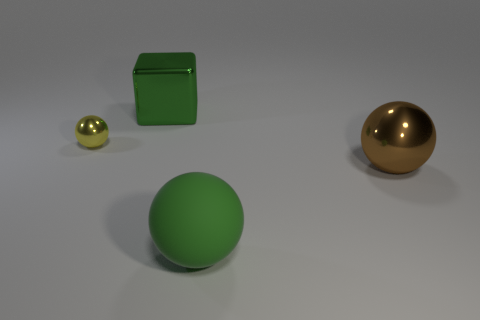What could the different sizes of the spheres suggest if this were an illustration for a story? The size contrast between the spheres could symbolize a variety of themes such as the idea of growth, with the smaller sphere representing a beginning phase and the larger one representing maturity. It might also suggest a parent-child relationship, or even a visual metaphor for the David and Goliath concept where a small entity stands against a much larger one. 